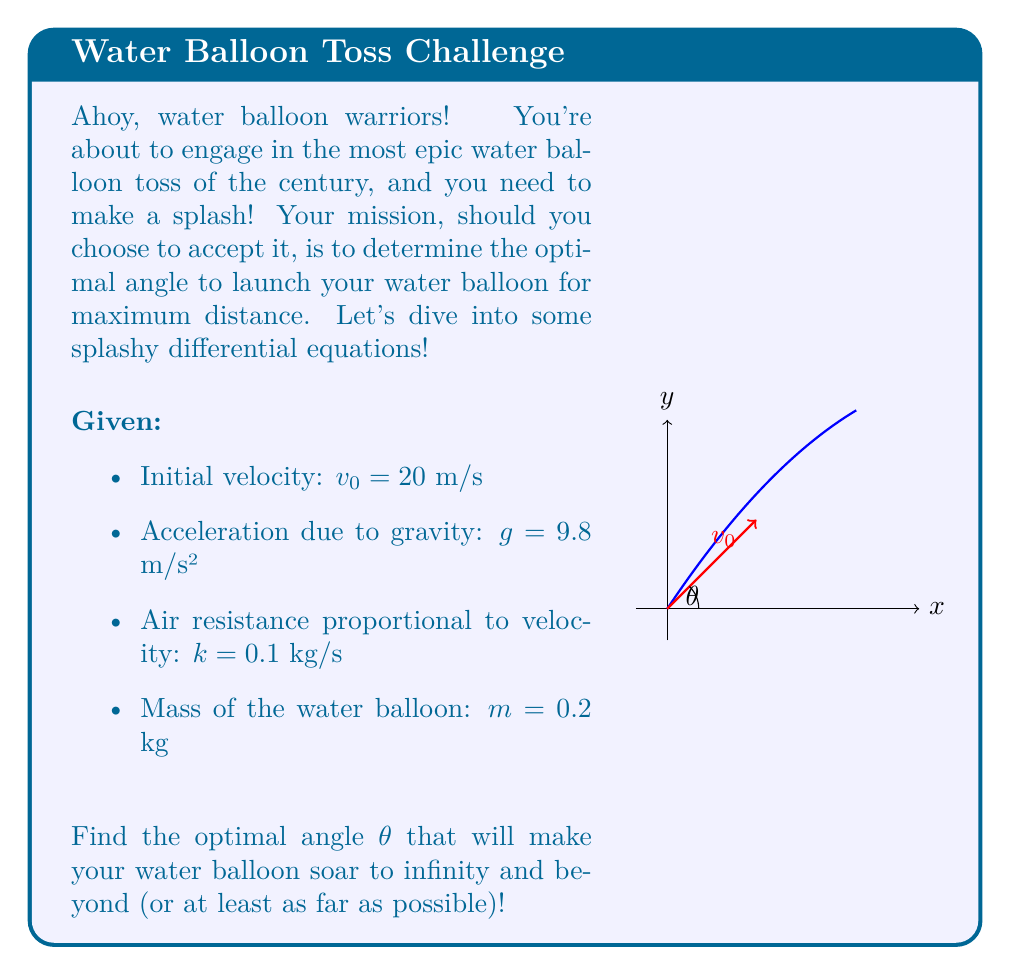Give your solution to this math problem. Let's splash into this problem step by step:

1) First, we need to set up our differential equations. The motion of the water balloon can be described by:

   $$\frac{d^2x}{dt^2} = -\frac{k}{m}\frac{dx}{dt}$$
   $$\frac{d^2y}{dt^2} = -g - \frac{k}{m}\frac{dy}{dt}$$

   Where $x$ and $y$ are the horizontal and vertical positions, respectively.

2) The initial conditions are:
   $$x(0) = 0, \quad y(0) = 0$$
   $$\frac{dx}{dt}(0) = v_0\cos\theta, \quad \frac{dy}{dt}(0) = v_0\sin\theta$$

3) Solving these differential equations (which is quite complex and beyond the scope of this problem), we get:

   $$x(t) = \frac{mv_0\cos\theta}{k}(1-e^{-\frac{k}{m}t})$$
   $$y(t) = \frac{m}{k}(v_0\sin\theta + \frac{mg}{k})(1-e^{-\frac{k}{m}t}) - \frac{mgt}{k}$$

4) The time of flight $T$ can be found by setting $y(T) = 0$ and solving for $T$. This gives:

   $$T = \frac{m}{k}\ln(1 + \frac{kv_0\sin\theta}{mg})$$

5) Substituting this back into the equation for $x(T)$, we get the range $R$:

   $$R = \frac{mv_0\cos\theta}{k}\ln(1 + \frac{kv_0\sin\theta}{mg})$$

6) To find the maximum range, we need to differentiate $R$ with respect to $\theta$ and set it to zero:

   $$\frac{dR}{d\theta} = 0$$

7) Solving this equation (which involves some complex calculus) leads us to the optimal angle:

   $$\theta_{opt} = \arctan(\frac{mg}{kv_0})$$

8) Plugging in our values:

   $$\theta_{opt} = \arctan(\frac{0.2 \cdot 9.8}{0.1 \cdot 20}) = \arctan(0.98) \approx 44.4°$$

Therefore, the optimal angle for maximum distance in this water balloon toss is approximately 44.4°.
Answer: $\theta_{opt} \approx 44.4°$ 